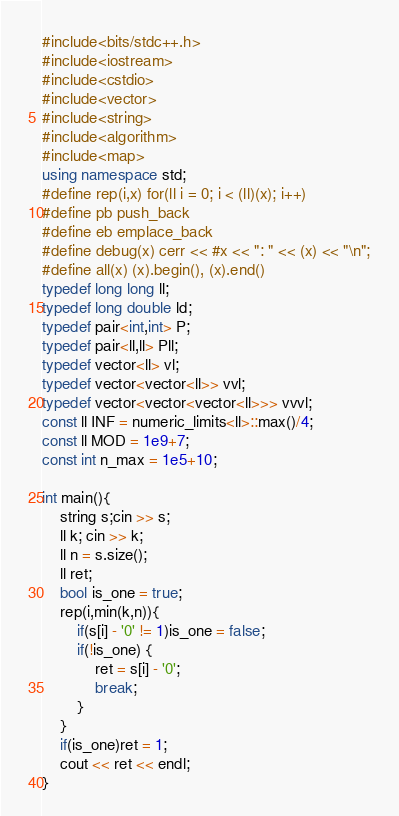Convert code to text. <code><loc_0><loc_0><loc_500><loc_500><_C++_>#include<bits/stdc++.h>
#include<iostream>
#include<cstdio>
#include<vector>
#include<string>
#include<algorithm>
#include<map>
using namespace std;
#define rep(i,x) for(ll i = 0; i < (ll)(x); i++)
#define pb push_back
#define eb emplace_back
#define debug(x) cerr << #x << ": " << (x) << "\n";
#define all(x) (x).begin(), (x).end()
typedef long long ll;
typedef long double ld;
typedef pair<int,int> P;
typedef pair<ll,ll> Pll;
typedef vector<ll> vl;
typedef vector<vector<ll>> vvl;
typedef vector<vector<vector<ll>>> vvvl;
const ll INF = numeric_limits<ll>::max()/4;
const ll MOD = 1e9+7;
const int n_max = 1e5+10;

int main(){
    string s;cin >> s;
    ll k; cin >> k;
    ll n = s.size();
    ll ret;
    bool is_one = true;
    rep(i,min(k,n)){
        if(s[i] - '0' != 1)is_one = false;
        if(!is_one) {
            ret = s[i] - '0';
            break;
        }
    }
    if(is_one)ret = 1;
    cout << ret << endl;
}</code> 